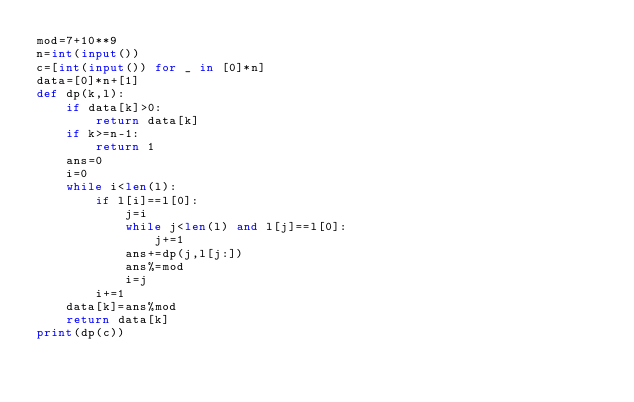Convert code to text. <code><loc_0><loc_0><loc_500><loc_500><_Python_>mod=7+10**9
n=int(input())
c=[int(input()) for _ in [0]*n]
data=[0]*n+[1]
def dp(k,l):
    if data[k]>0:
        return data[k]
    if k>=n-1:
        return 1
    ans=0
    i=0
    while i<len(l):
        if l[i]==l[0]:
            j=i
            while j<len(l) and l[j]==l[0]:
                j+=1
            ans+=dp(j,l[j:])
            ans%=mod
            i=j
        i+=1
    data[k]=ans%mod
    return data[k]
print(dp(c))</code> 